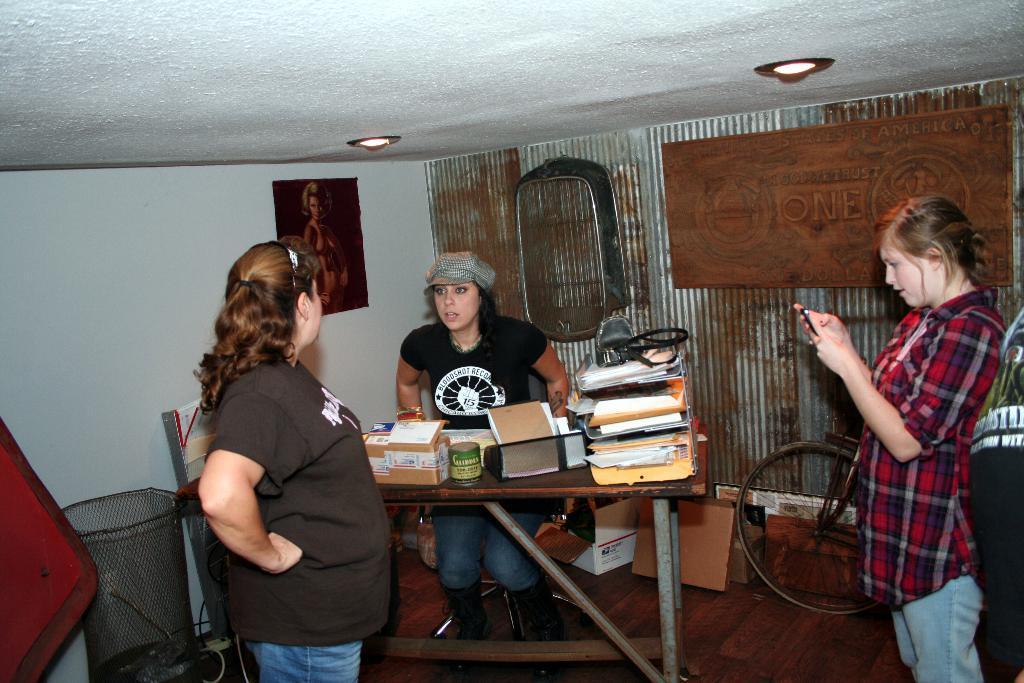Could you give a brief overview of what you see in this image? In this picture we can see one woman sitting in front of the table in the middle of the picture, on right side of picture we can see one woman looking at mobile, there are some of the files on the table here, on the left side of picture there is a one more woman in the background we can see a wall and a portrait here, in the ceiling we can see a light and also we can see bicycle in the background and some of the boxes here. 